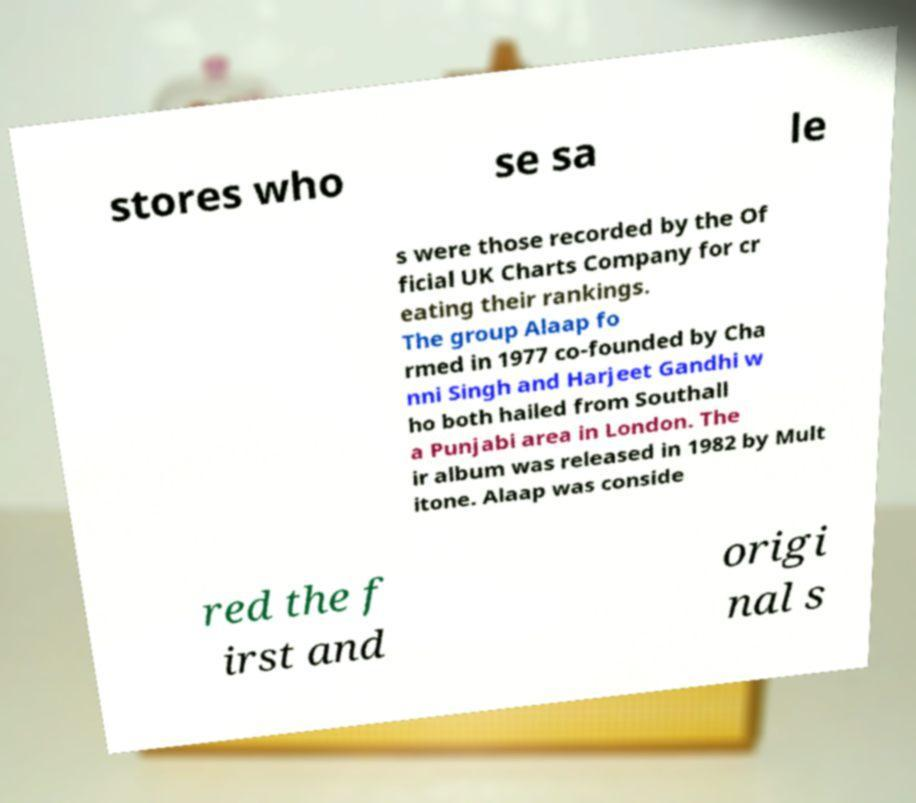Please identify and transcribe the text found in this image. stores who se sa le s were those recorded by the Of ficial UK Charts Company for cr eating their rankings. The group Alaap fo rmed in 1977 co-founded by Cha nni Singh and Harjeet Gandhi w ho both hailed from Southall a Punjabi area in London. The ir album was released in 1982 by Mult itone. Alaap was conside red the f irst and origi nal s 